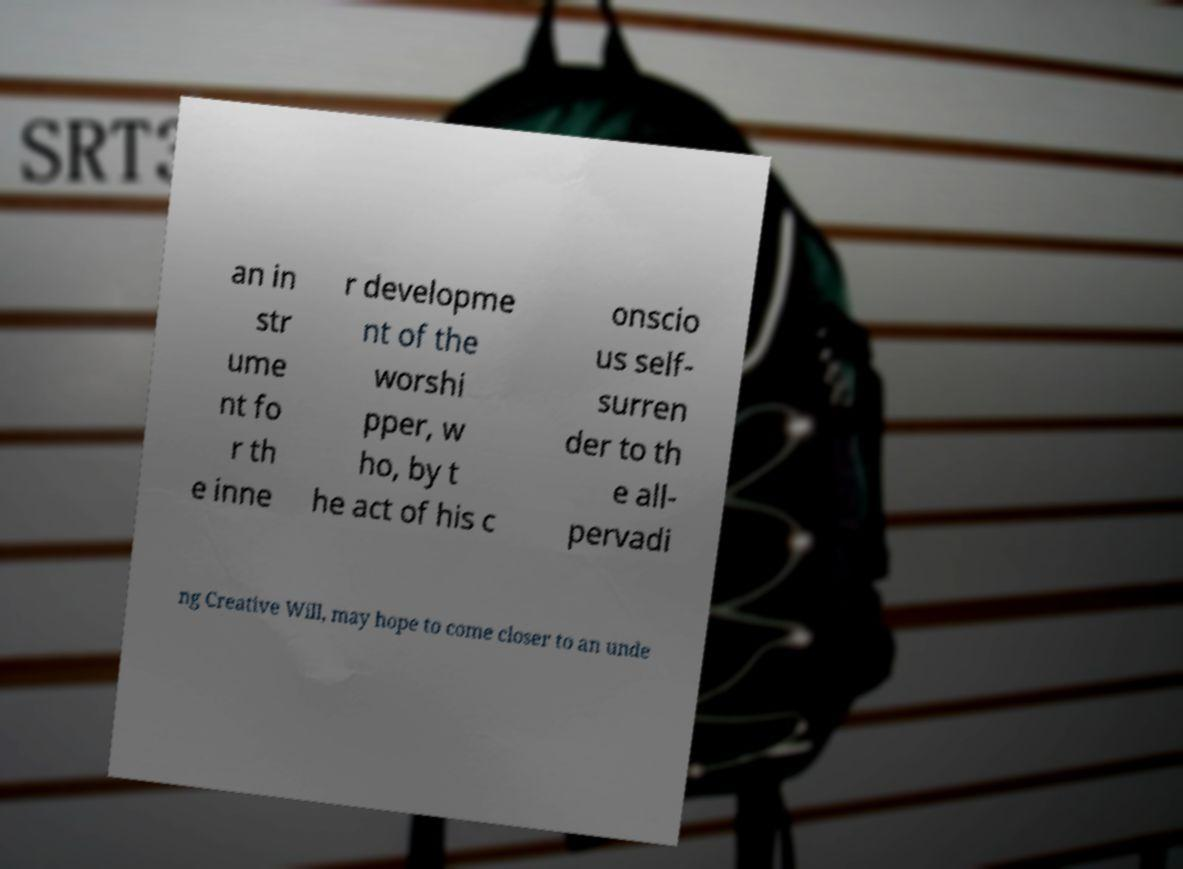I need the written content from this picture converted into text. Can you do that? an in str ume nt fo r th e inne r developme nt of the worshi pper, w ho, by t he act of his c onscio us self- surren der to th e all- pervadi ng Creative Will, may hope to come closer to an unde 